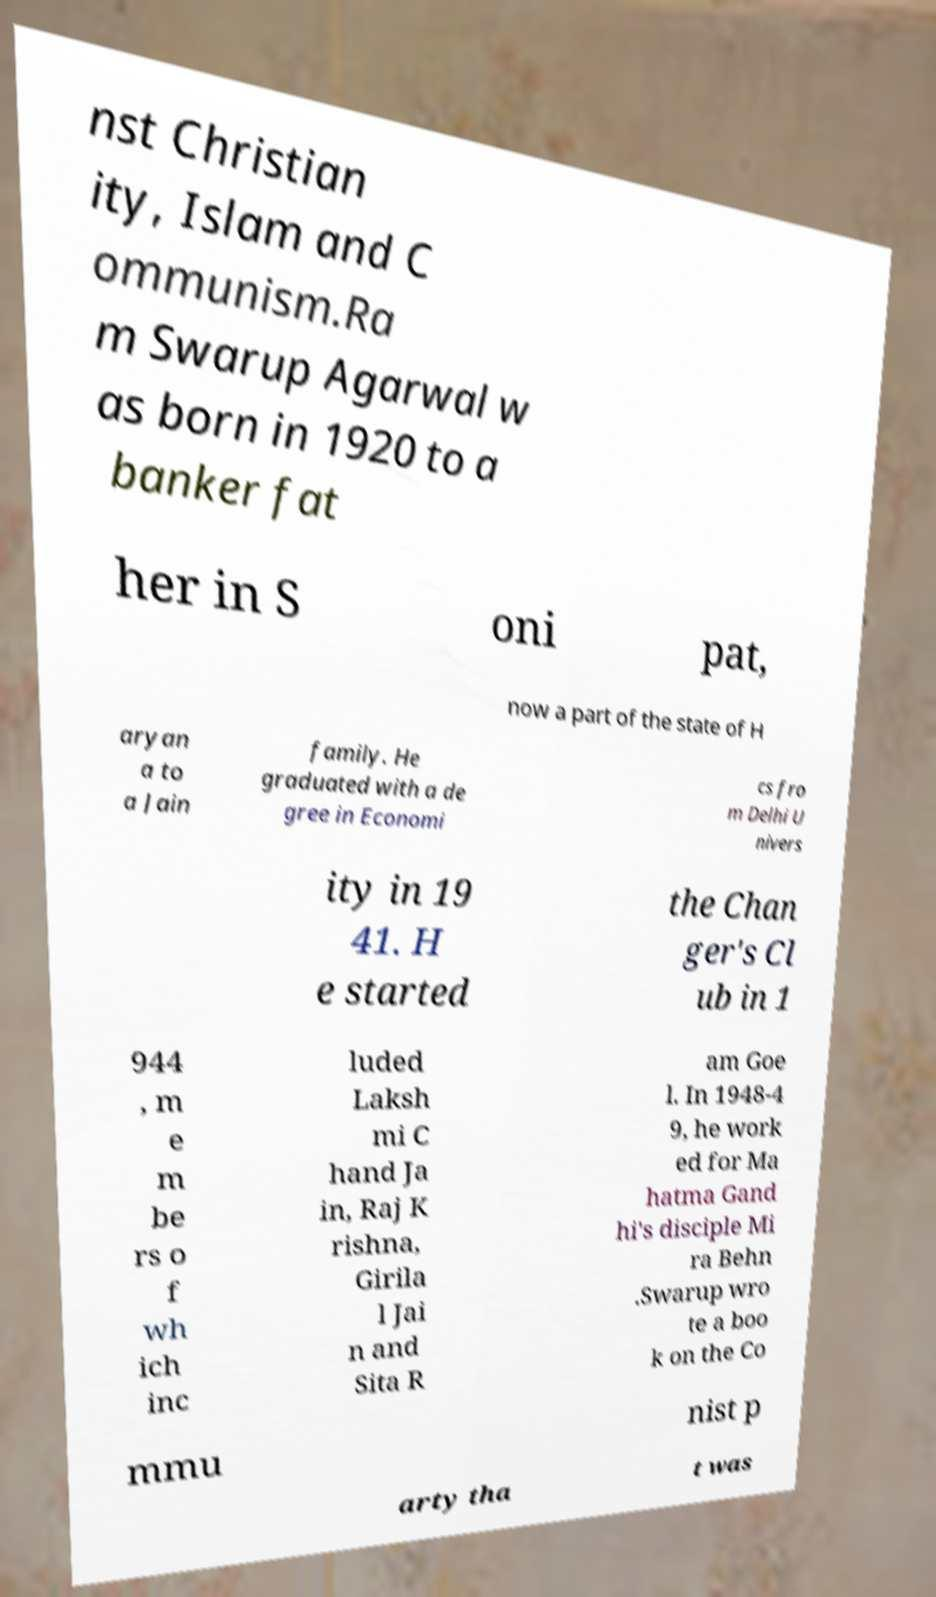Can you accurately transcribe the text from the provided image for me? nst Christian ity, Islam and C ommunism.Ra m Swarup Agarwal w as born in 1920 to a banker fat her in S oni pat, now a part of the state of H aryan a to a Jain family. He graduated with a de gree in Economi cs fro m Delhi U nivers ity in 19 41. H e started the Chan ger's Cl ub in 1 944 , m e m be rs o f wh ich inc luded Laksh mi C hand Ja in, Raj K rishna, Girila l Jai n and Sita R am Goe l. In 1948-4 9, he work ed for Ma hatma Gand hi's disciple Mi ra Behn .Swarup wro te a boo k on the Co mmu nist p arty tha t was 